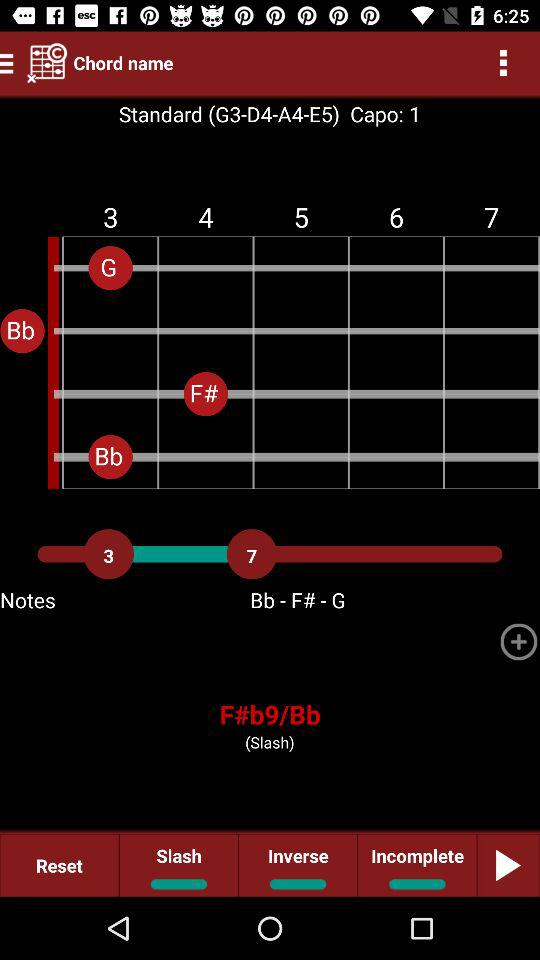What is the chord name?
When the provided information is insufficient, respond with <no answer>. <no answer> 